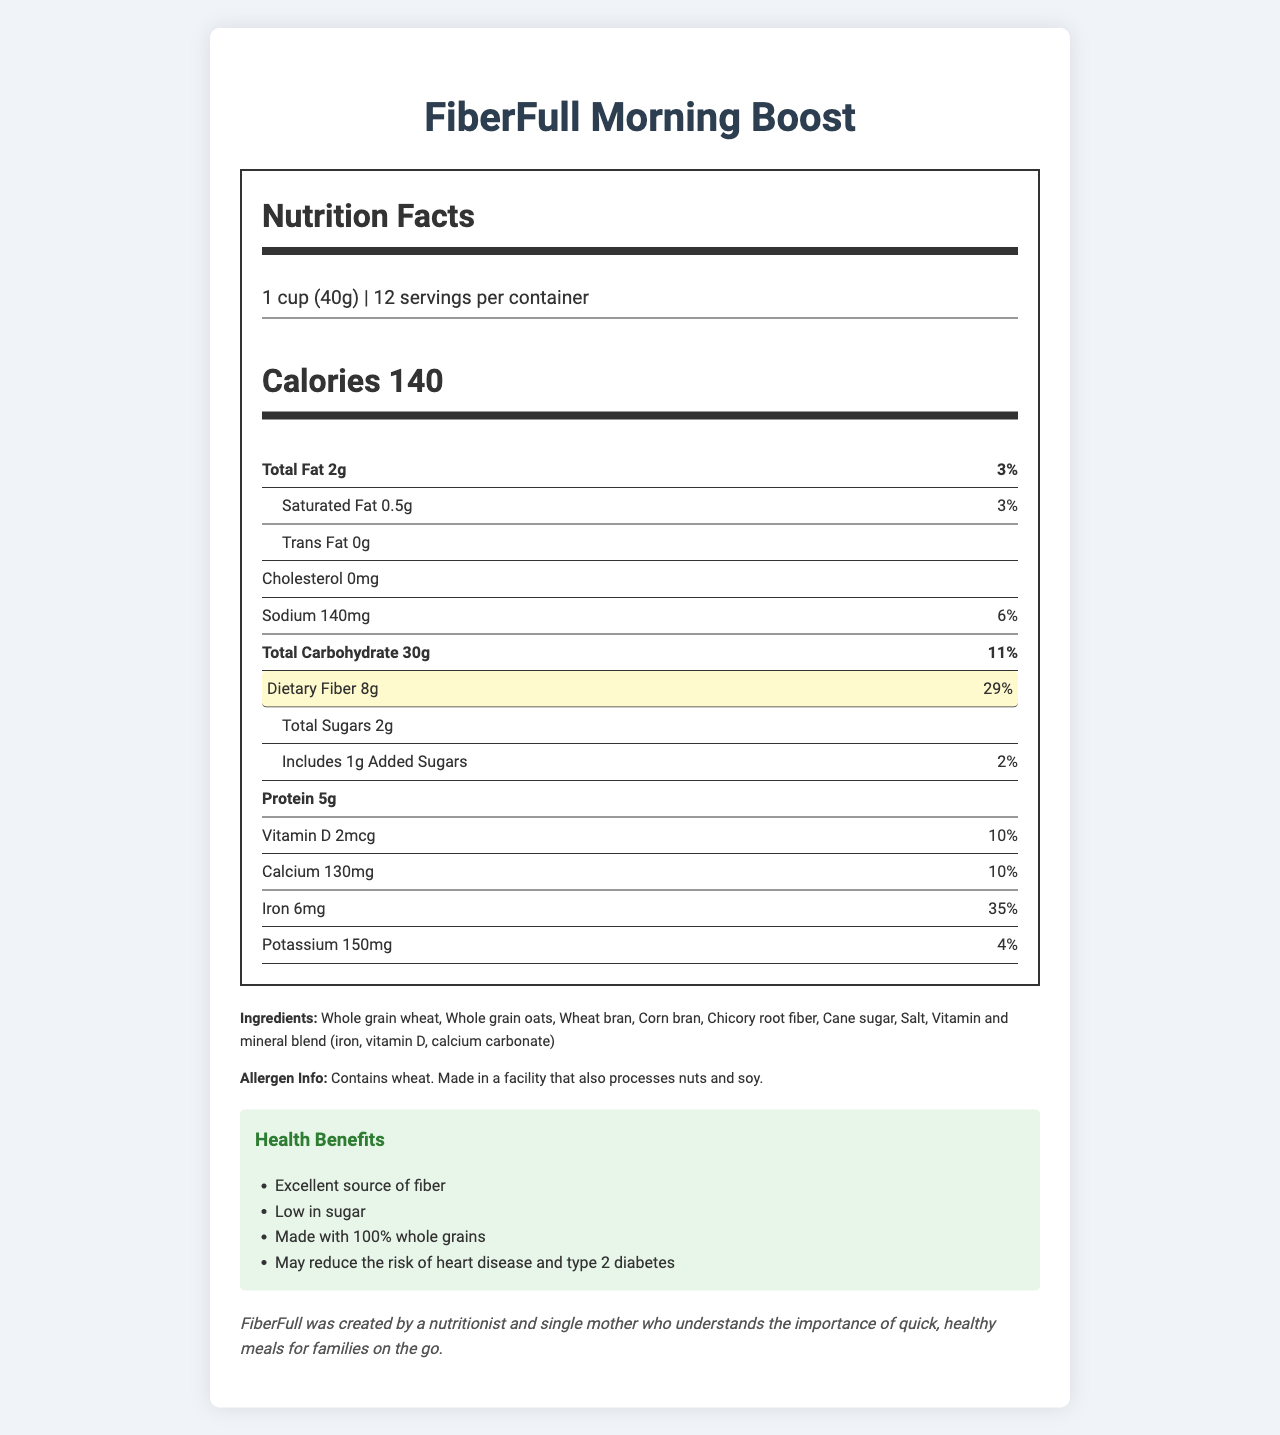how many calories are there per serving? The document specifies that there are 140 calories per serving of FiberFull Morning Boost.
Answer: 140 what is the serving size? The serving size is directly mentioned as "1 cup (40g)" in the nutrition facts label.
Answer: 1 cup (40g) how many grams of dietary fiber are in each serving? The document highlights that each serving contains 8 grams of dietary fiber.
Answer: 8g identify a key ingredient in FiberFull Morning Boost One of the key ingredients listed is "Whole grain wheat."
Answer: Whole grain wheat what percentage of daily value of iron does one serving provide? The iron content per serving is listed as providing 35% of the daily value.
Answer: 35% which of the following is NOT an ingredient in FiberFull Morning Boost? A. Corn bran B. Wheat bran C. Soy protein D. Chicory root fiber "Soy protein" is not listed among the ingredients.
Answer: C. Soy protein which health benefit is NOT mentioned for FiberFull Morning Boost? A. Excellent source of fiber B. Boosts immunity C. May reduce the risk of heart disease and type 2 diabetes D. Low in sugar "Boosts immunity" is not one of the health claims mentioned in the document.
Answer: B. Boosts immunity does FiberFull Morning Boost contain any saturated fat? The document shows that FiberFull Morning Boost contains 0.5g of saturated fat per serving.
Answer: Yes provide a summary of the document The summary captures the nutritional content, ingredient highlights, health benefits, marketing points, and sustainability aspects mentioned in the document.
Answer: FiberFull Morning Boost is a low-sugar, high-fiber breakfast cereal with detailed nutrition facts, including 140 calories per serving, 8g of dietary fiber, and 5g of protein. It is made from whole grains and other natural ingredients and comes with health benefits like being an excellent source of fiber and potentially reducing heart disease and type 2 diabetes risk. The cereal has a kid-approved taste and supports healthy digestion while being environmentally friendly with recycled packaging. what is the total sugar content per serving? The total sugar content for each serving is specified as 2 grams.
Answer: 2g how many servings are there per container? The nutrition facts label states that there are 12 servings per container.
Answer: 12 what is the allergen information provided? The allergen information indicates the presence of wheat and the possibility of cross-contamination with nuts and soy.
Answer: Contains wheat. Made in a facility that also processes nuts and soy. is the packaging made from recycled materials? The document mentions that the packaging is made from 100% recycled materials.
Answer: Yes how many grams of protein are in each serving? Each serving of FiberFull Morning Boost contains 5 grams of protein.
Answer: 5g what is the main reason stated for the creation of FiberFull? The brand story mentions that FiberFull was created by a nutritionist and single mother to provide quick, healthy meals for families on the go.
Answer: To provide quick, healthy meals for families on the go what is the total amount of fat in each serving? The total fat content per serving is listed as 2 grams.
Answer: 2g how much potassium is in each serving? Each serving contains 150 milligrams of potassium.
Answer: 150mg who is the creator of FiberFull Morning Boost? The brand story section mentions that FiberFull was created by a nutritionist and single mother.
Answer: A nutritionist and single mother what is the cholesterol content per serving? The nutrition facts indicate that there is no cholesterol in each serving.
Answer: 0mg what is the exact amount of added sugars in each serving? The document specifies that there is 1 gram of added sugars per serving.
Answer: 1g who processes fiberfull morning boost? The document does not provide information about the manufacturer or processing facility for FiberFull Morning Boost.
Answer: Not enough information 